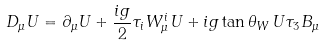<formula> <loc_0><loc_0><loc_500><loc_500>D _ { \mu } U = \partial _ { \mu } U + \frac { { i } g } { 2 } \tau _ { i } W ^ { i } _ { \mu } U + { i } g \tan \theta _ { W } \, U \tau _ { 3 } B _ { \mu }</formula> 